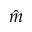Convert formula to latex. <formula><loc_0><loc_0><loc_500><loc_500>\hat { m }</formula> 